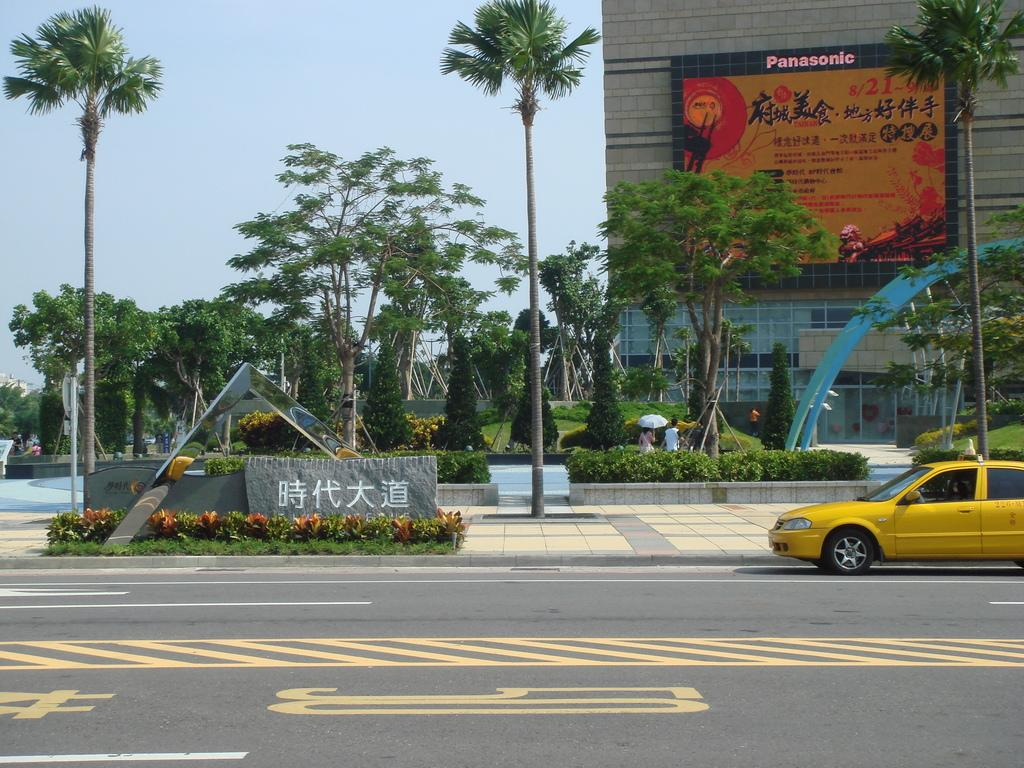<image>
Relay a brief, clear account of the picture shown. A taxi outside of a building that says Panasonic on it. 